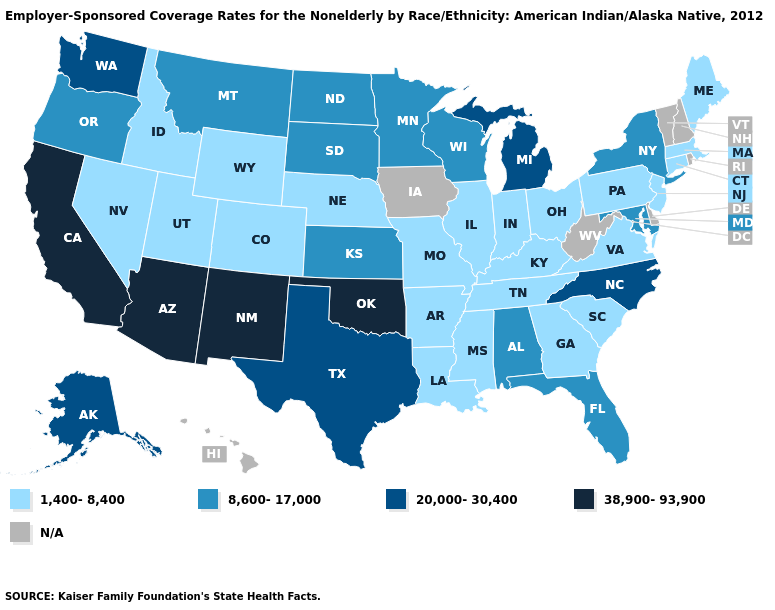What is the value of Indiana?
Answer briefly. 1,400-8,400. Name the states that have a value in the range 1,400-8,400?
Keep it brief. Arkansas, Colorado, Connecticut, Georgia, Idaho, Illinois, Indiana, Kentucky, Louisiana, Maine, Massachusetts, Mississippi, Missouri, Nebraska, Nevada, New Jersey, Ohio, Pennsylvania, South Carolina, Tennessee, Utah, Virginia, Wyoming. Does Texas have the lowest value in the South?
Answer briefly. No. Which states hav the highest value in the West?
Quick response, please. Arizona, California, New Mexico. Is the legend a continuous bar?
Concise answer only. No. Name the states that have a value in the range N/A?
Concise answer only. Delaware, Hawaii, Iowa, New Hampshire, Rhode Island, Vermont, West Virginia. Which states have the lowest value in the Northeast?
Answer briefly. Connecticut, Maine, Massachusetts, New Jersey, Pennsylvania. Name the states that have a value in the range 1,400-8,400?
Concise answer only. Arkansas, Colorado, Connecticut, Georgia, Idaho, Illinois, Indiana, Kentucky, Louisiana, Maine, Massachusetts, Mississippi, Missouri, Nebraska, Nevada, New Jersey, Ohio, Pennsylvania, South Carolina, Tennessee, Utah, Virginia, Wyoming. Name the states that have a value in the range 38,900-93,900?
Concise answer only. Arizona, California, New Mexico, Oklahoma. Which states have the lowest value in the USA?
Keep it brief. Arkansas, Colorado, Connecticut, Georgia, Idaho, Illinois, Indiana, Kentucky, Louisiana, Maine, Massachusetts, Mississippi, Missouri, Nebraska, Nevada, New Jersey, Ohio, Pennsylvania, South Carolina, Tennessee, Utah, Virginia, Wyoming. Name the states that have a value in the range 20,000-30,400?
Be succinct. Alaska, Michigan, North Carolina, Texas, Washington. What is the highest value in states that border Pennsylvania?
Write a very short answer. 8,600-17,000. 